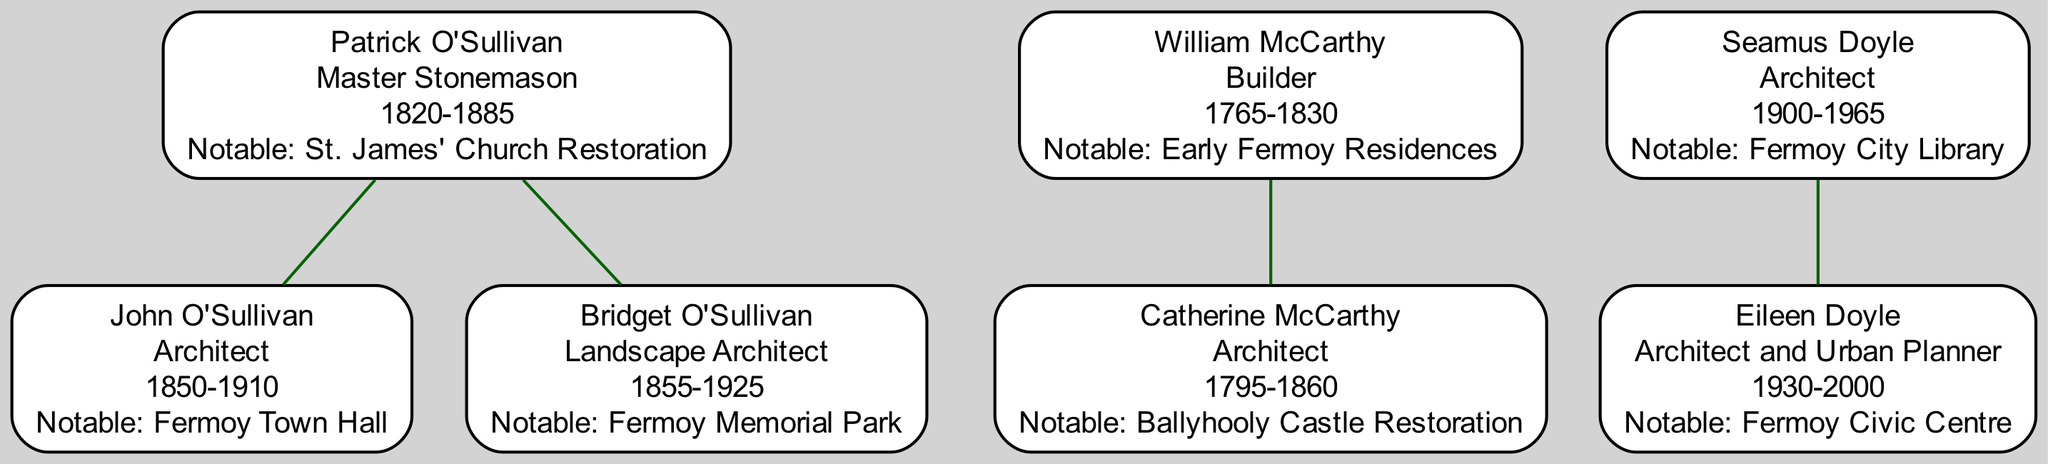What is the occupation of Patrick O'Sullivan? According to the diagram, Patrick O'Sullivan is listed under the O'Sullivan family and his occupation is stated as "Master Stonemason."
Answer: Master Stonemason Who is the child of William McCarthy? In the McCarthy family section of the diagram, William McCarthy has one child, who is Catherine McCarthy.
Answer: Catherine McCarthy What notable work is associated with John O'Sullivan? Under the O'Sullivan family section, John O'Sullivan is noted for his work on "Fermoy Town Hall."
Answer: Fermoy Town Hall How many notable architects are in the Doyle family? According to the diagram, the Doyle family has one notable architect, Seamus Doyle.
Answer: 1 Which family does Bridget O'Sullivan belong to? By examining the nodes in the diagram, Bridget O'Sullivan is part of the O'Sullivan family.
Answer: O'Sullivan What is the first name of the structural engineer who is a descendant of Catherine McCarthy? The diagram shows that the child of Catherine McCarthy, who is a structural engineer, is named Thomas McCarthy.
Answer: Thomas Which family has the earliest birth year listed? By reviewing the birth years in the diagram, it is noted that William McCarthy was born in 1765, making the McCarthy family the earliest.
Answer: McCarthy List the notable work of Eileen Doyle. The diagram indicates that Eileen Doyle has contributed to the "Fermoy Civic Centre," which is her notable work.
Answer: Fermoy Civic Centre How many generations are represented in the O'Sullivan family? Analyzing the O'Sullivan family section, there are three generations: Patrick, his children John and Bridget, and John's son Michael.
Answer: 3 